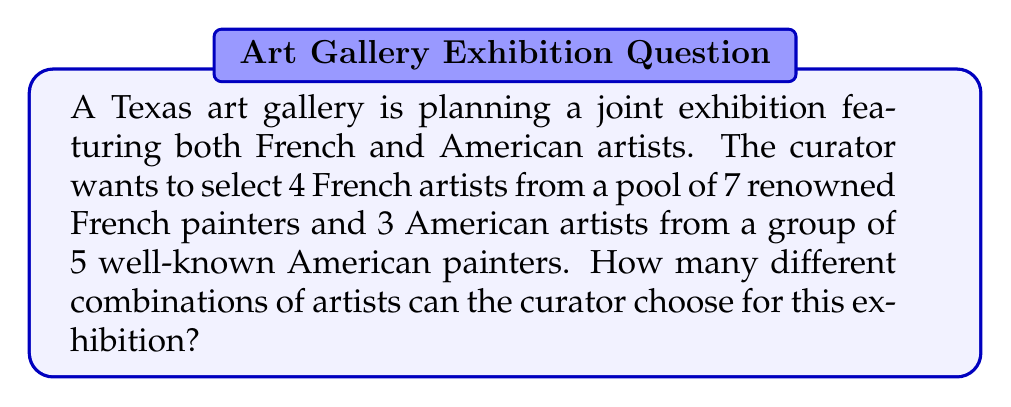Give your solution to this math problem. To solve this problem, we need to use the combination formula for both the French and American artist selections, then multiply the results together.

1. For the French artists:
   We need to choose 4 out of 7 artists. This can be represented as $\binom{7}{4}$.
   
   $$\binom{7}{4} = \frac{7!}{4!(7-4)!} = \frac{7!}{4!3!} = \frac{7 \cdot 6 \cdot 5 \cdot 4}{4 \cdot 3 \cdot 2 \cdot 1} = 35$$

2. For the American artists:
   We need to choose 3 out of 5 artists. This can be represented as $\binom{5}{3}$.
   
   $$\binom{5}{3} = \frac{5!}{3!(5-3)!} = \frac{5!}{3!2!} = \frac{5 \cdot 4 \cdot 3}{3 \cdot 2 \cdot 1} = 10$$

3. To find the total number of possible combinations, we multiply these results:

   $$35 \cdot 10 = 350$$

This multiplication is valid because for each possible selection of French artists, there are 10 possible selections of American artists, and vice versa. This is an application of the multiplication principle in combinatorics.
Answer: The curator can choose 350 different combinations of artists for the exhibition. 